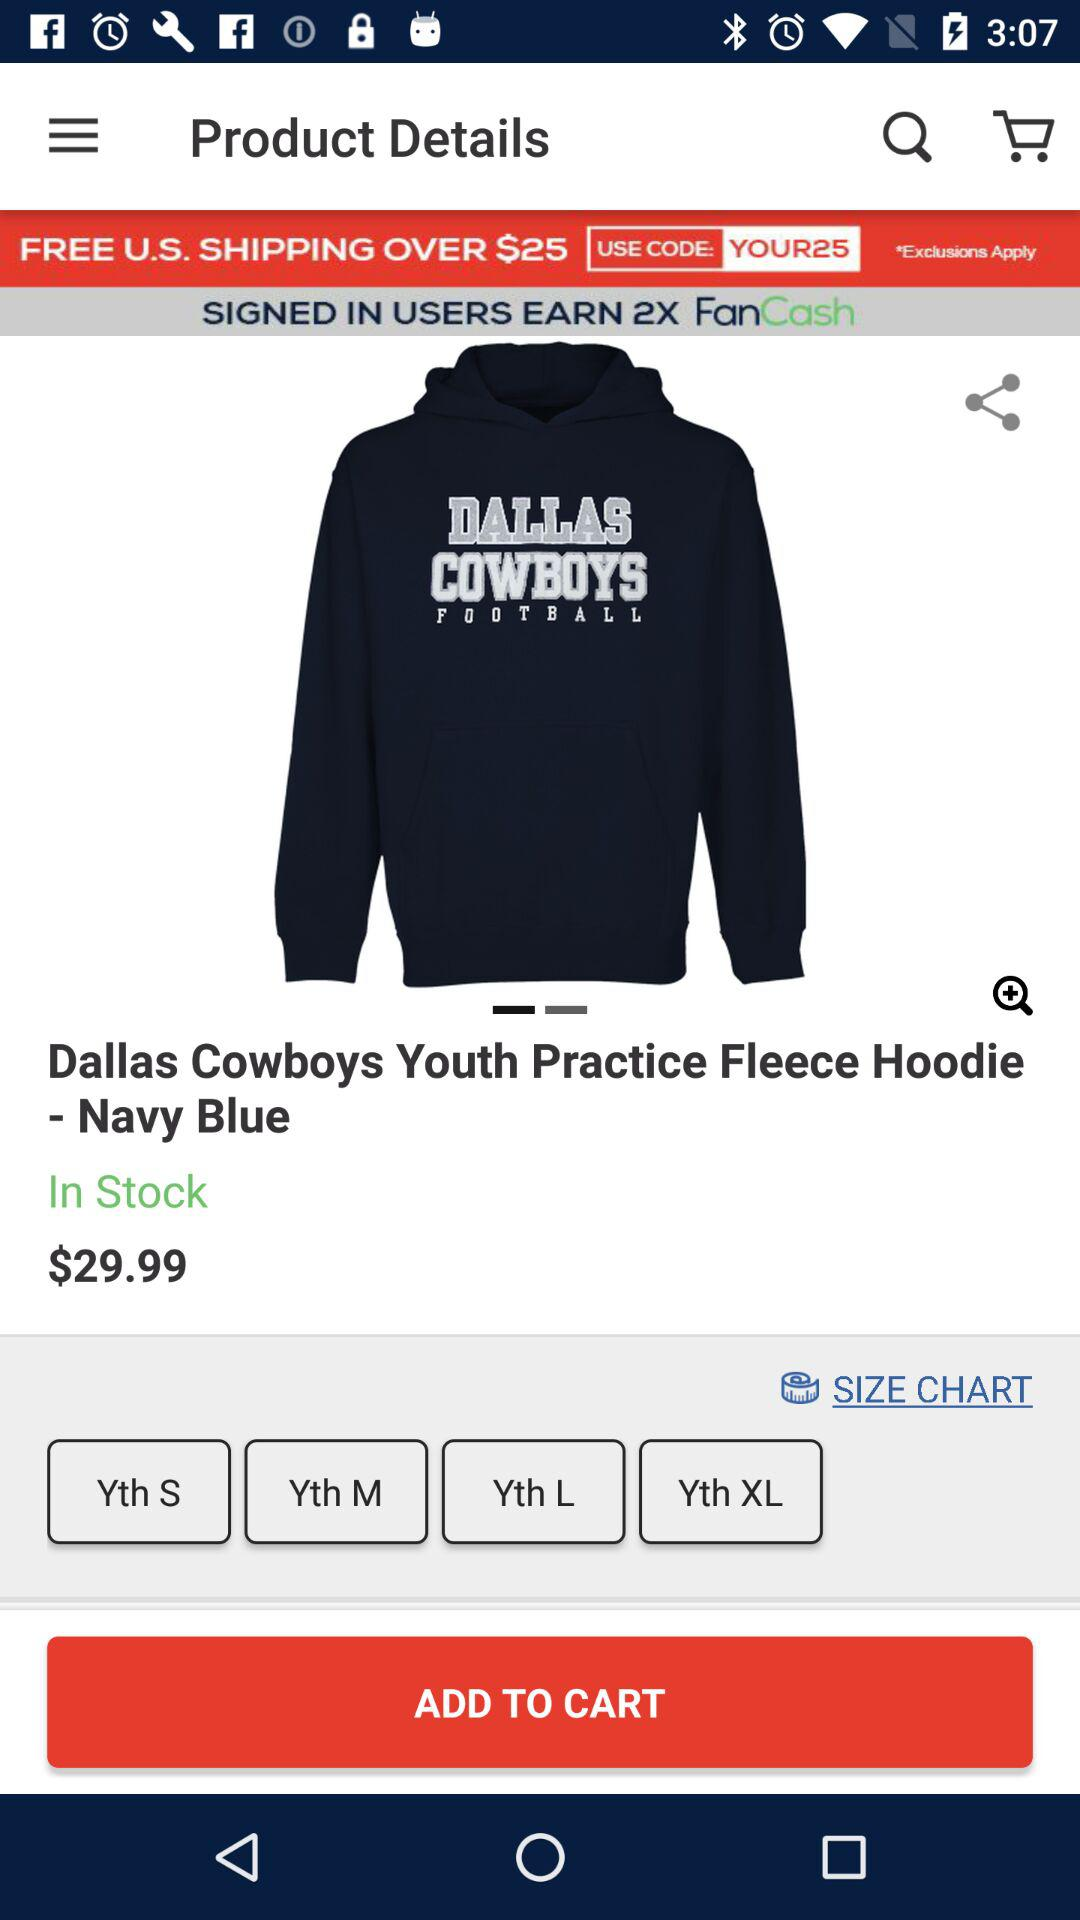How many sizes are available for the hoodie?
Answer the question using a single word or phrase. 4 